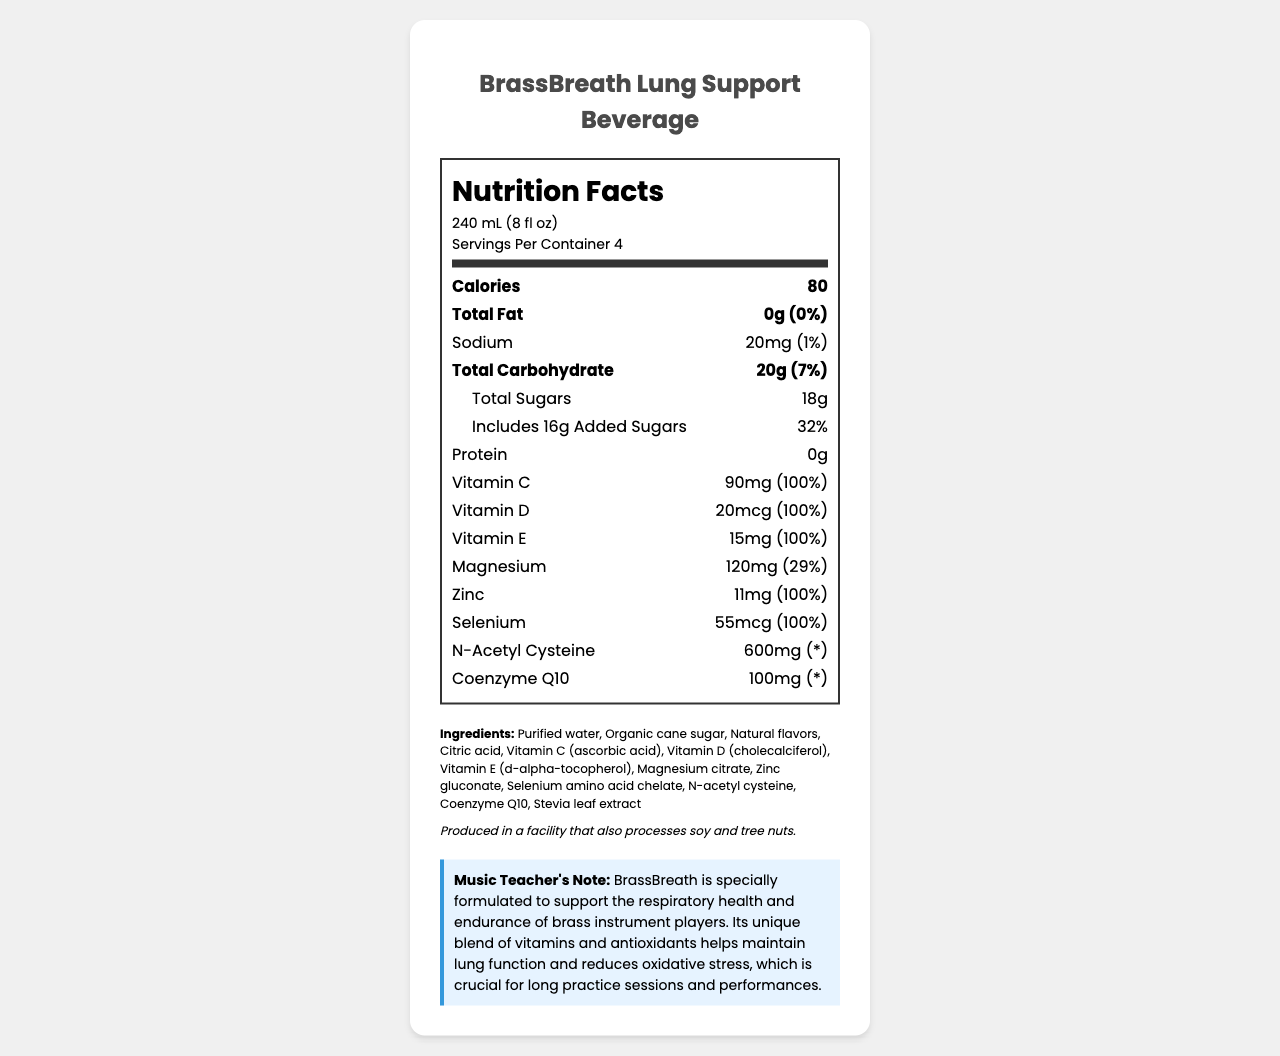what is the serving size for BrassBreath Lung Support Beverage? The serving size is mentioned at the top part of the nutrition label under "Nutrition Facts."
Answer: 240 mL (8 fl oz) how many servings are there per container? This information is displayed under the serving size in the nutrition label.
Answer: 4 how many calories per serving does BrassBreath Lung Support Beverage have? The number of calories per serving is listed right below the servings per container.
Answer: 80 what is the amount of vitamin C in one serving? The amount of Vitamin C per serving is listed in the part of the nutrition label that specifies the nutritional facts about different vitamins.
Answer: 90mg what is the amount of added sugars in one serving? The amount of added sugars is listed under total sugars in the nutrition item section of the document.
Answer: 16g which of the following vitamins are present in BrassBreath Lung Support Beverage? A. Vitamin A B. Vitamin B12 C. Vitamin E D. Vitamin K Vitamin E is listed in the nutrition facts section, while Vitamin A, Vitamin B12, and Vitamin K are absent.
Answer: C. Vitamin E which mineral has the highest daily value percentage per serving? A. Sodium B. Magnesium C. Zinc D. Selenium The nutrition facts section shows Zinc with a daily value percentage of 100%, higher than Sodium (1%), Magnesium (29%), and Selenium (100%).
Answer: C. Zinc does BrassBreath Lung Support Beverage contain any protein? The nutrition facts state 0g of protein, indicating there is no protein in the beverage.
Answer: No is the product allergen-free? The allergen information states that it is produced in a facility that also processes soy and tree nuts.
Answer: No summarize the main idea of this document. The document provides detailed nutritional information about BrassBreath Lung Support Beverage, highlighting its benefits for musicians, specifically brass instrument players, along with ingredients and allergen notes.
Answer: BrassBreath Lung Support Beverage is a vitamin-fortified drink designed to support the respiratory health and endurance of brass instrument players. It contains various vitamins and minerals beneficial for lung function and endurance, with nutritional information including serving size, calories, vitamins, and ingredients. what is the recommended daily value percentage of Coenzyme Q10 per serving? The daily value percentage for Coenzyme Q10 is not provided in the document. It is marked with an asterisk (*) in the nutrition facts section.
Answer: Cannot be determined 